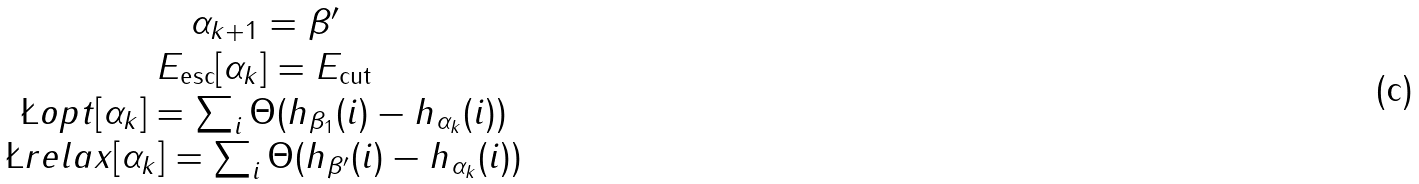<formula> <loc_0><loc_0><loc_500><loc_500>\begin{array} { c } \alpha _ { k + 1 } = \beta ^ { \prime } \\ E _ { \text {esc} } [ \alpha _ { k } ] = E _ { \text {cut} } \\ \L o p t [ \alpha _ { k } ] = \sum _ { i } \Theta ( h _ { \beta _ { 1 } } ( i ) - h _ { \alpha _ { k } } ( i ) ) \\ \L r e l a x [ \alpha _ { k } ] = \sum _ { i } \Theta ( h _ { \beta ^ { \prime } } ( i ) - h _ { \alpha _ { k } } ( i ) ) \end{array}</formula> 